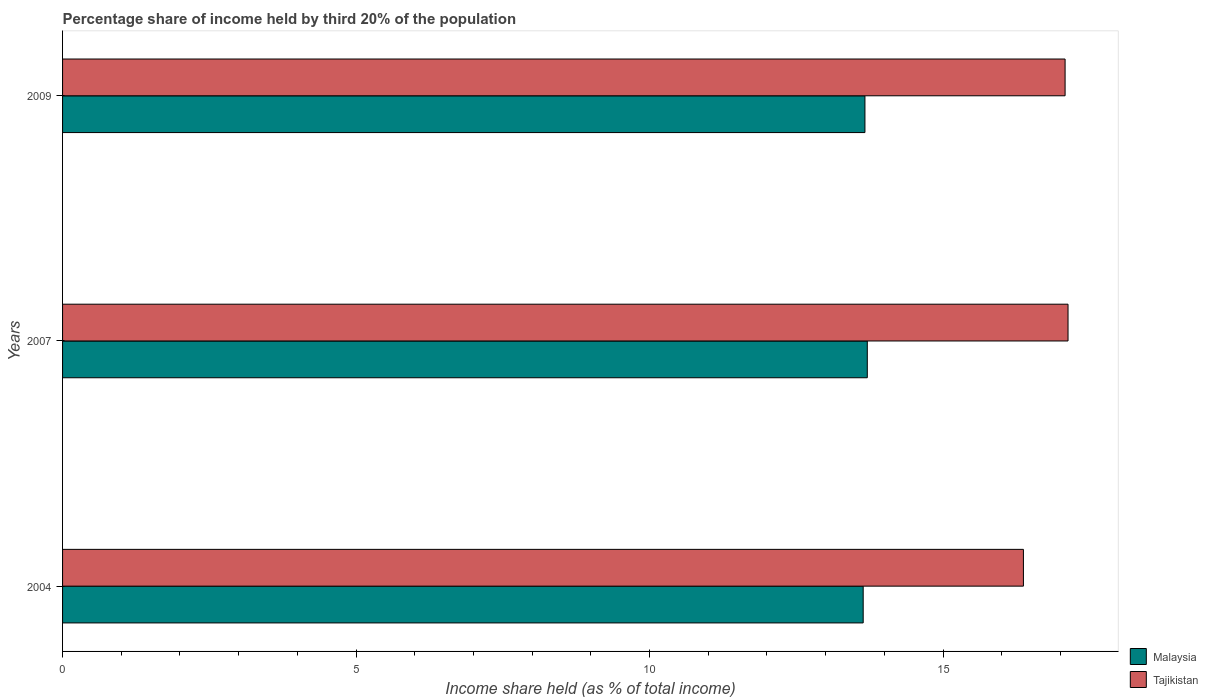How many different coloured bars are there?
Your answer should be very brief. 2. Are the number of bars per tick equal to the number of legend labels?
Your answer should be compact. Yes. What is the label of the 2nd group of bars from the top?
Make the answer very short. 2007. What is the share of income held by third 20% of the population in Malaysia in 2004?
Offer a terse response. 13.64. Across all years, what is the maximum share of income held by third 20% of the population in Malaysia?
Your answer should be very brief. 13.71. Across all years, what is the minimum share of income held by third 20% of the population in Tajikistan?
Keep it short and to the point. 16.37. In which year was the share of income held by third 20% of the population in Malaysia maximum?
Keep it short and to the point. 2007. In which year was the share of income held by third 20% of the population in Malaysia minimum?
Ensure brevity in your answer.  2004. What is the total share of income held by third 20% of the population in Malaysia in the graph?
Ensure brevity in your answer.  41.02. What is the difference between the share of income held by third 20% of the population in Malaysia in 2007 and that in 2009?
Offer a terse response. 0.04. What is the difference between the share of income held by third 20% of the population in Malaysia in 2004 and the share of income held by third 20% of the population in Tajikistan in 2007?
Provide a short and direct response. -3.49. What is the average share of income held by third 20% of the population in Malaysia per year?
Provide a succinct answer. 13.67. In the year 2007, what is the difference between the share of income held by third 20% of the population in Malaysia and share of income held by third 20% of the population in Tajikistan?
Offer a terse response. -3.42. In how many years, is the share of income held by third 20% of the population in Malaysia greater than 5 %?
Offer a very short reply. 3. What is the ratio of the share of income held by third 20% of the population in Malaysia in 2004 to that in 2007?
Provide a succinct answer. 0.99. What is the difference between the highest and the second highest share of income held by third 20% of the population in Tajikistan?
Your answer should be very brief. 0.05. What is the difference between the highest and the lowest share of income held by third 20% of the population in Tajikistan?
Provide a succinct answer. 0.76. In how many years, is the share of income held by third 20% of the population in Tajikistan greater than the average share of income held by third 20% of the population in Tajikistan taken over all years?
Make the answer very short. 2. What does the 1st bar from the top in 2007 represents?
Ensure brevity in your answer.  Tajikistan. What does the 1st bar from the bottom in 2004 represents?
Your answer should be very brief. Malaysia. Does the graph contain grids?
Offer a very short reply. No. How many legend labels are there?
Give a very brief answer. 2. What is the title of the graph?
Ensure brevity in your answer.  Percentage share of income held by third 20% of the population. Does "Colombia" appear as one of the legend labels in the graph?
Give a very brief answer. No. What is the label or title of the X-axis?
Offer a very short reply. Income share held (as % of total income). What is the Income share held (as % of total income) of Malaysia in 2004?
Offer a very short reply. 13.64. What is the Income share held (as % of total income) of Tajikistan in 2004?
Your answer should be compact. 16.37. What is the Income share held (as % of total income) of Malaysia in 2007?
Give a very brief answer. 13.71. What is the Income share held (as % of total income) in Tajikistan in 2007?
Offer a terse response. 17.13. What is the Income share held (as % of total income) in Malaysia in 2009?
Provide a short and direct response. 13.67. What is the Income share held (as % of total income) of Tajikistan in 2009?
Offer a very short reply. 17.08. Across all years, what is the maximum Income share held (as % of total income) in Malaysia?
Give a very brief answer. 13.71. Across all years, what is the maximum Income share held (as % of total income) in Tajikistan?
Offer a very short reply. 17.13. Across all years, what is the minimum Income share held (as % of total income) in Malaysia?
Provide a succinct answer. 13.64. Across all years, what is the minimum Income share held (as % of total income) of Tajikistan?
Your answer should be very brief. 16.37. What is the total Income share held (as % of total income) of Malaysia in the graph?
Make the answer very short. 41.02. What is the total Income share held (as % of total income) in Tajikistan in the graph?
Your answer should be compact. 50.58. What is the difference between the Income share held (as % of total income) in Malaysia in 2004 and that in 2007?
Keep it short and to the point. -0.07. What is the difference between the Income share held (as % of total income) in Tajikistan in 2004 and that in 2007?
Your response must be concise. -0.76. What is the difference between the Income share held (as % of total income) of Malaysia in 2004 and that in 2009?
Provide a succinct answer. -0.03. What is the difference between the Income share held (as % of total income) of Tajikistan in 2004 and that in 2009?
Your answer should be compact. -0.71. What is the difference between the Income share held (as % of total income) of Malaysia in 2004 and the Income share held (as % of total income) of Tajikistan in 2007?
Give a very brief answer. -3.49. What is the difference between the Income share held (as % of total income) in Malaysia in 2004 and the Income share held (as % of total income) in Tajikistan in 2009?
Provide a short and direct response. -3.44. What is the difference between the Income share held (as % of total income) in Malaysia in 2007 and the Income share held (as % of total income) in Tajikistan in 2009?
Keep it short and to the point. -3.37. What is the average Income share held (as % of total income) of Malaysia per year?
Your answer should be compact. 13.67. What is the average Income share held (as % of total income) of Tajikistan per year?
Give a very brief answer. 16.86. In the year 2004, what is the difference between the Income share held (as % of total income) in Malaysia and Income share held (as % of total income) in Tajikistan?
Your answer should be very brief. -2.73. In the year 2007, what is the difference between the Income share held (as % of total income) in Malaysia and Income share held (as % of total income) in Tajikistan?
Offer a terse response. -3.42. In the year 2009, what is the difference between the Income share held (as % of total income) of Malaysia and Income share held (as % of total income) of Tajikistan?
Make the answer very short. -3.41. What is the ratio of the Income share held (as % of total income) in Tajikistan in 2004 to that in 2007?
Your response must be concise. 0.96. What is the ratio of the Income share held (as % of total income) of Tajikistan in 2004 to that in 2009?
Offer a terse response. 0.96. What is the ratio of the Income share held (as % of total income) of Tajikistan in 2007 to that in 2009?
Offer a very short reply. 1. What is the difference between the highest and the second highest Income share held (as % of total income) of Malaysia?
Ensure brevity in your answer.  0.04. What is the difference between the highest and the lowest Income share held (as % of total income) in Malaysia?
Your response must be concise. 0.07. What is the difference between the highest and the lowest Income share held (as % of total income) of Tajikistan?
Offer a terse response. 0.76. 